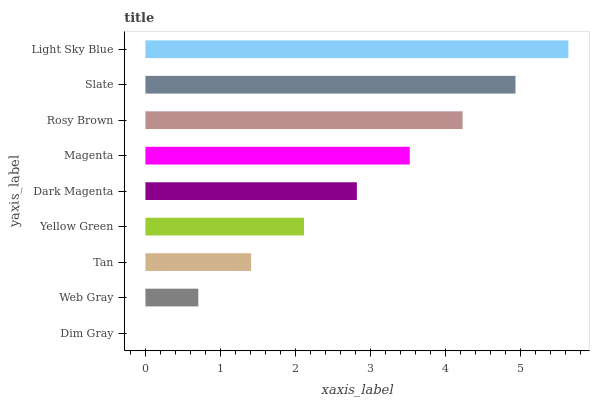Is Dim Gray the minimum?
Answer yes or no. Yes. Is Light Sky Blue the maximum?
Answer yes or no. Yes. Is Web Gray the minimum?
Answer yes or no. No. Is Web Gray the maximum?
Answer yes or no. No. Is Web Gray greater than Dim Gray?
Answer yes or no. Yes. Is Dim Gray less than Web Gray?
Answer yes or no. Yes. Is Dim Gray greater than Web Gray?
Answer yes or no. No. Is Web Gray less than Dim Gray?
Answer yes or no. No. Is Dark Magenta the high median?
Answer yes or no. Yes. Is Dark Magenta the low median?
Answer yes or no. Yes. Is Light Sky Blue the high median?
Answer yes or no. No. Is Tan the low median?
Answer yes or no. No. 